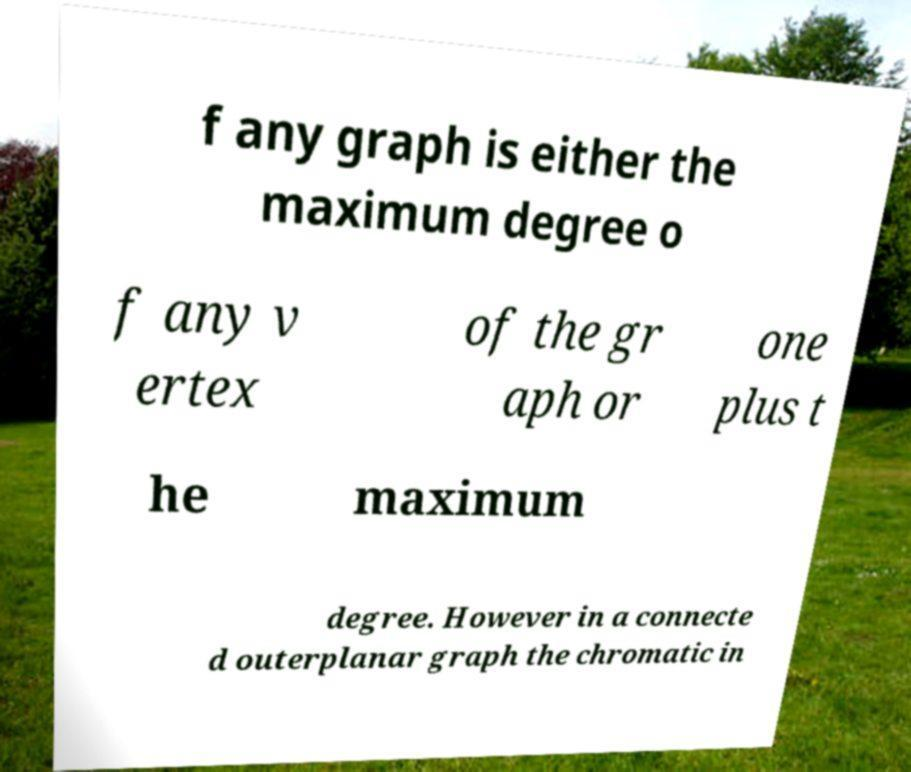Could you assist in decoding the text presented in this image and type it out clearly? f any graph is either the maximum degree o f any v ertex of the gr aph or one plus t he maximum degree. However in a connecte d outerplanar graph the chromatic in 